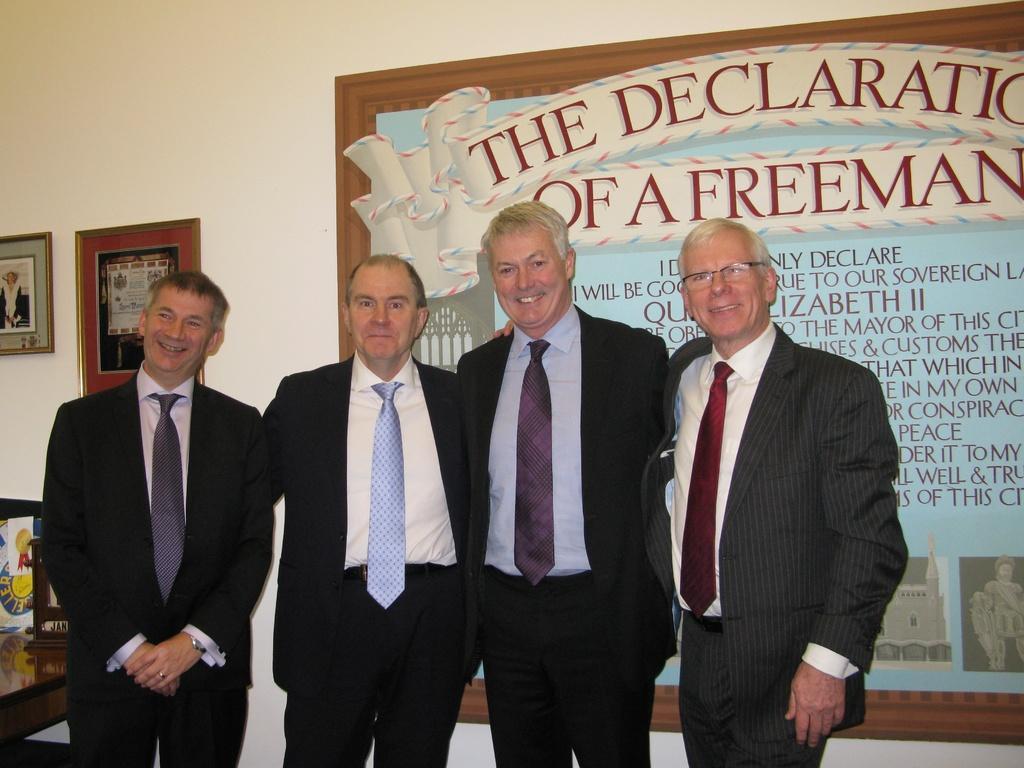Please provide a concise description of this image. 4 men are standing wearing suit. There is a suit at the left. There are photo frames at the back. 